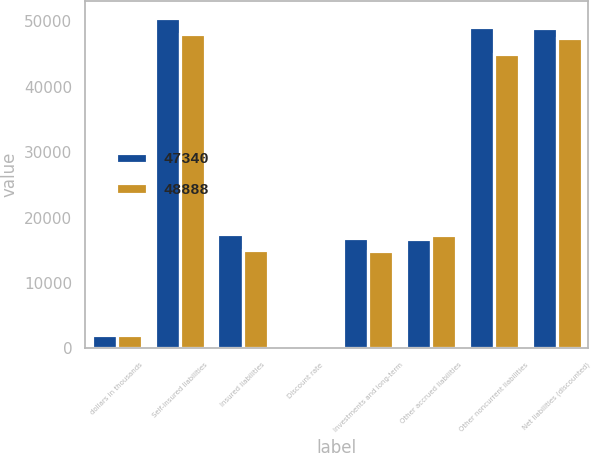<chart> <loc_0><loc_0><loc_500><loc_500><stacked_bar_chart><ecel><fcel>dollars in thousands<fcel>Self-insured liabilities<fcel>Insured liabilities<fcel>Discount rate<fcel>Investments and long-term<fcel>Other accrued liabilities<fcel>Other noncurrent liabilities<fcel>Net liabilities (discounted)<nl><fcel>47340<fcel>2013<fcel>50538<fcel>17497<fcel>0.98<fcel>16917<fcel>16657<fcel>49148<fcel>48888<nl><fcel>48888<fcel>2012<fcel>48019<fcel>15054<fcel>0.51<fcel>14822<fcel>17260<fcel>44902<fcel>47340<nl></chart> 